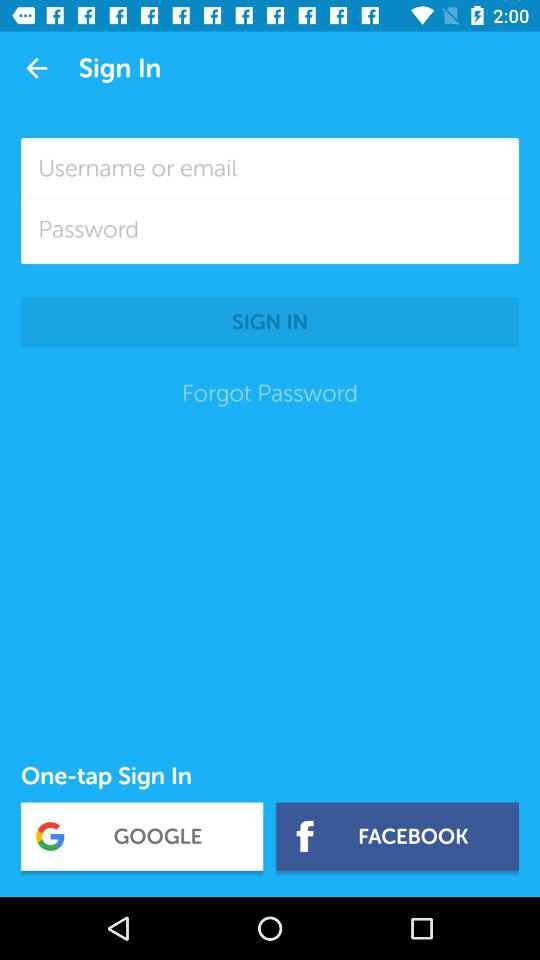What are the options to sign in? The options are "Username or email", "GOOGLE" and "FACEBOOK". 